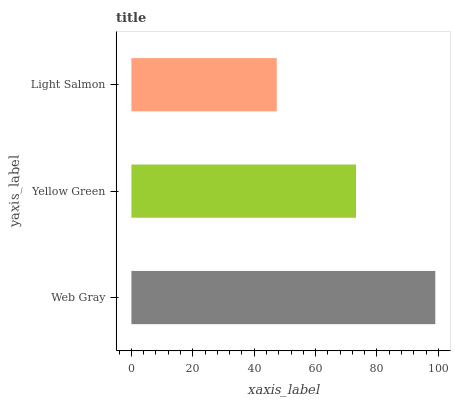Is Light Salmon the minimum?
Answer yes or no. Yes. Is Web Gray the maximum?
Answer yes or no. Yes. Is Yellow Green the minimum?
Answer yes or no. No. Is Yellow Green the maximum?
Answer yes or no. No. Is Web Gray greater than Yellow Green?
Answer yes or no. Yes. Is Yellow Green less than Web Gray?
Answer yes or no. Yes. Is Yellow Green greater than Web Gray?
Answer yes or no. No. Is Web Gray less than Yellow Green?
Answer yes or no. No. Is Yellow Green the high median?
Answer yes or no. Yes. Is Yellow Green the low median?
Answer yes or no. Yes. Is Light Salmon the high median?
Answer yes or no. No. Is Web Gray the low median?
Answer yes or no. No. 